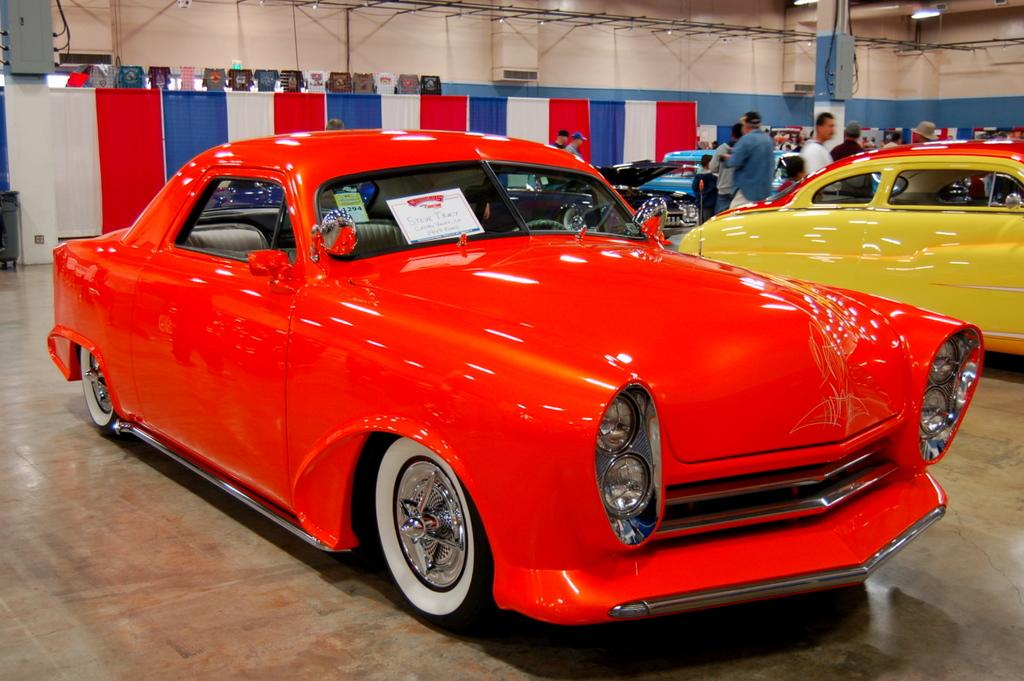What type of vehicles can be seen in the image? There are cars in the image. Who or what else is present in the image? There are people in the image. What is attached to the poles in the image? There are banners attached to poles in the image. What is hanging from a rope in the image? There are clothes hanging from a rope in the image. What part of a building is visible in the image? There is a ceiling visible in the image. What is attached to the roof in the image? There is a light attached to the roof in the image. What type of appliance can be seen in the image? There is no appliance present in the image. What is the source of the mist in the image? There is no mist present in the image. 